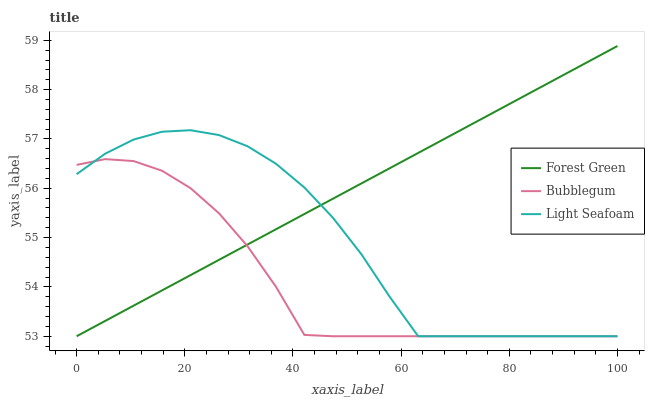Does Bubblegum have the minimum area under the curve?
Answer yes or no. Yes. Does Forest Green have the maximum area under the curve?
Answer yes or no. Yes. Does Light Seafoam have the minimum area under the curve?
Answer yes or no. No. Does Light Seafoam have the maximum area under the curve?
Answer yes or no. No. Is Forest Green the smoothest?
Answer yes or no. Yes. Is Light Seafoam the roughest?
Answer yes or no. Yes. Is Bubblegum the smoothest?
Answer yes or no. No. Is Bubblegum the roughest?
Answer yes or no. No. Does Forest Green have the lowest value?
Answer yes or no. Yes. Does Forest Green have the highest value?
Answer yes or no. Yes. Does Light Seafoam have the highest value?
Answer yes or no. No. Does Light Seafoam intersect Bubblegum?
Answer yes or no. Yes. Is Light Seafoam less than Bubblegum?
Answer yes or no. No. Is Light Seafoam greater than Bubblegum?
Answer yes or no. No. 